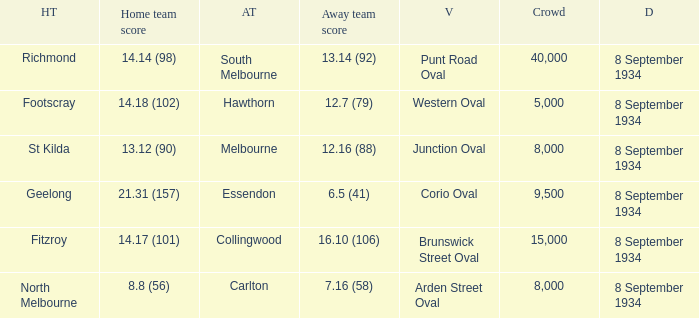When the Home team scored 14.14 (98), what did the Away Team score? 13.14 (92). 